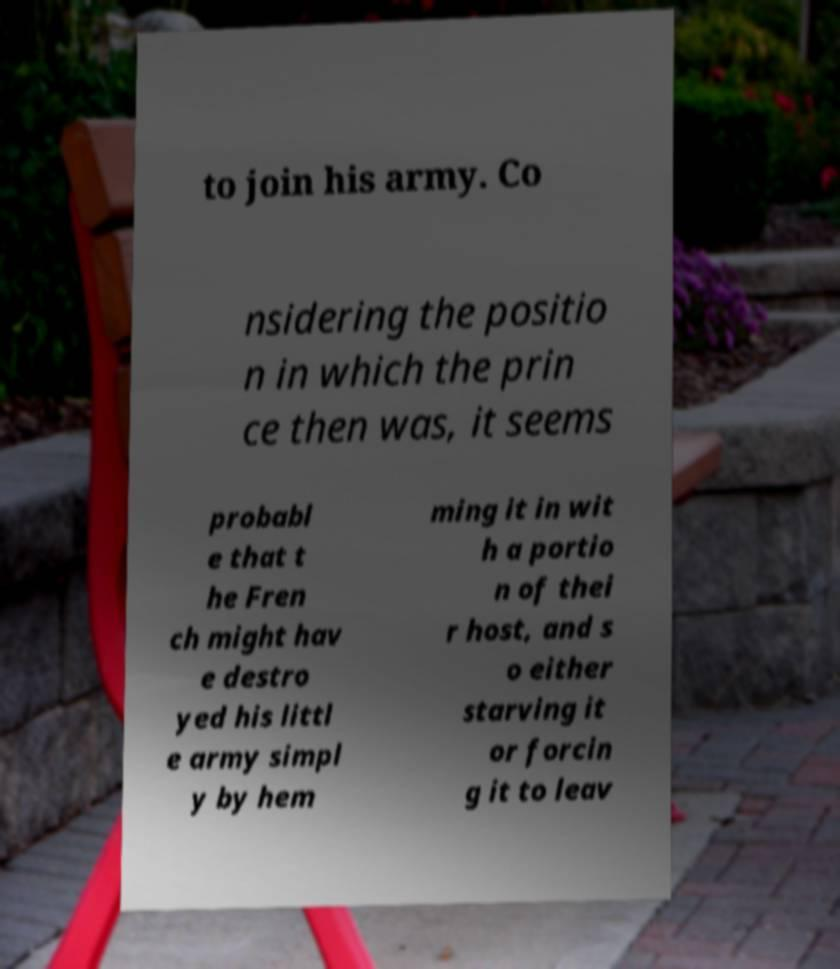Can you read and provide the text displayed in the image?This photo seems to have some interesting text. Can you extract and type it out for me? to join his army. Co nsidering the positio n in which the prin ce then was, it seems probabl e that t he Fren ch might hav e destro yed his littl e army simpl y by hem ming it in wit h a portio n of thei r host, and s o either starving it or forcin g it to leav 